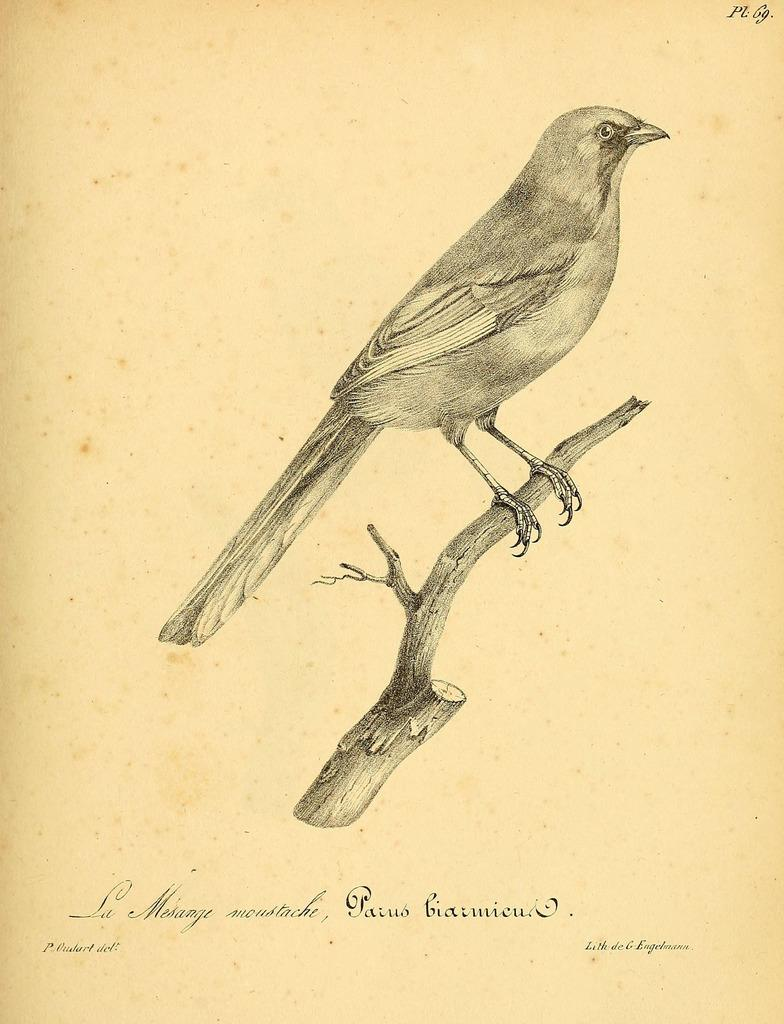What is depicted in the image? There is a sketch of a bird in the image. Where is the bird located in the image? The bird is sitting on a stem in the image. Is there any text or writing in the image? Yes, there is writing on the image. How does the bird stretch its wings at the party in the image? There is no party depicted in the image, and the bird is not shown stretching its wings. 